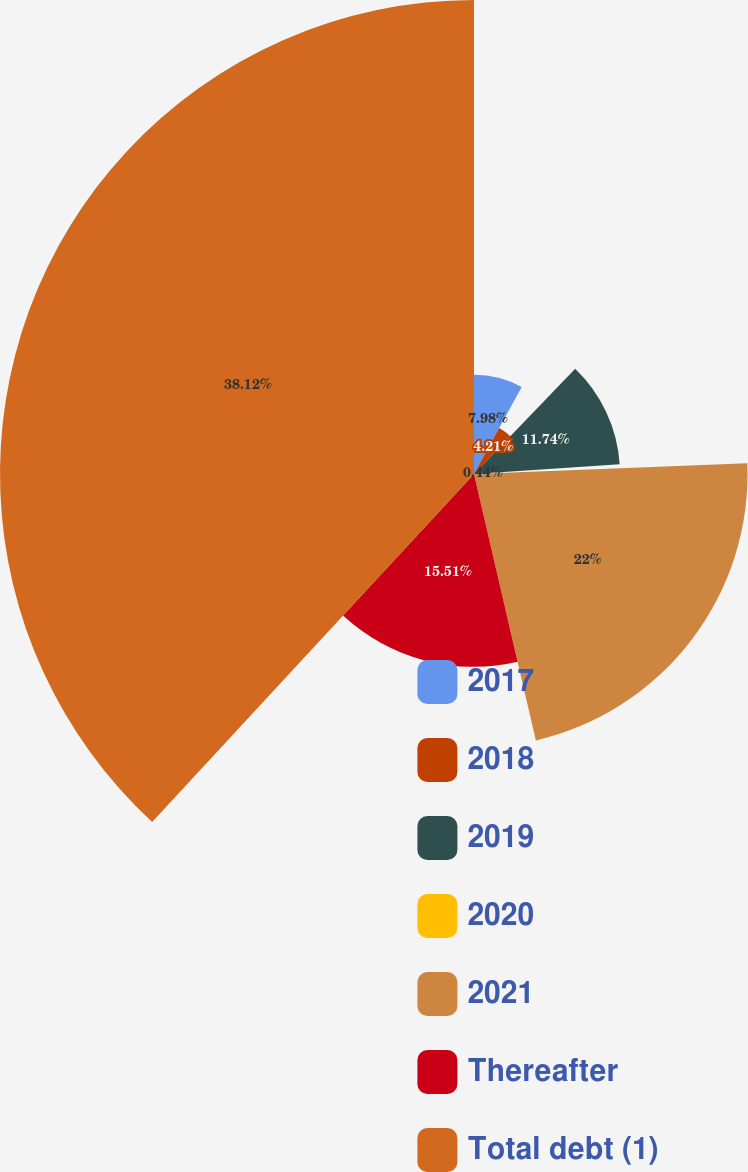Convert chart. <chart><loc_0><loc_0><loc_500><loc_500><pie_chart><fcel>2017<fcel>2018<fcel>2019<fcel>2020<fcel>2021<fcel>Thereafter<fcel>Total debt (1)<nl><fcel>7.98%<fcel>4.21%<fcel>11.74%<fcel>0.44%<fcel>22.0%<fcel>15.51%<fcel>38.12%<nl></chart> 